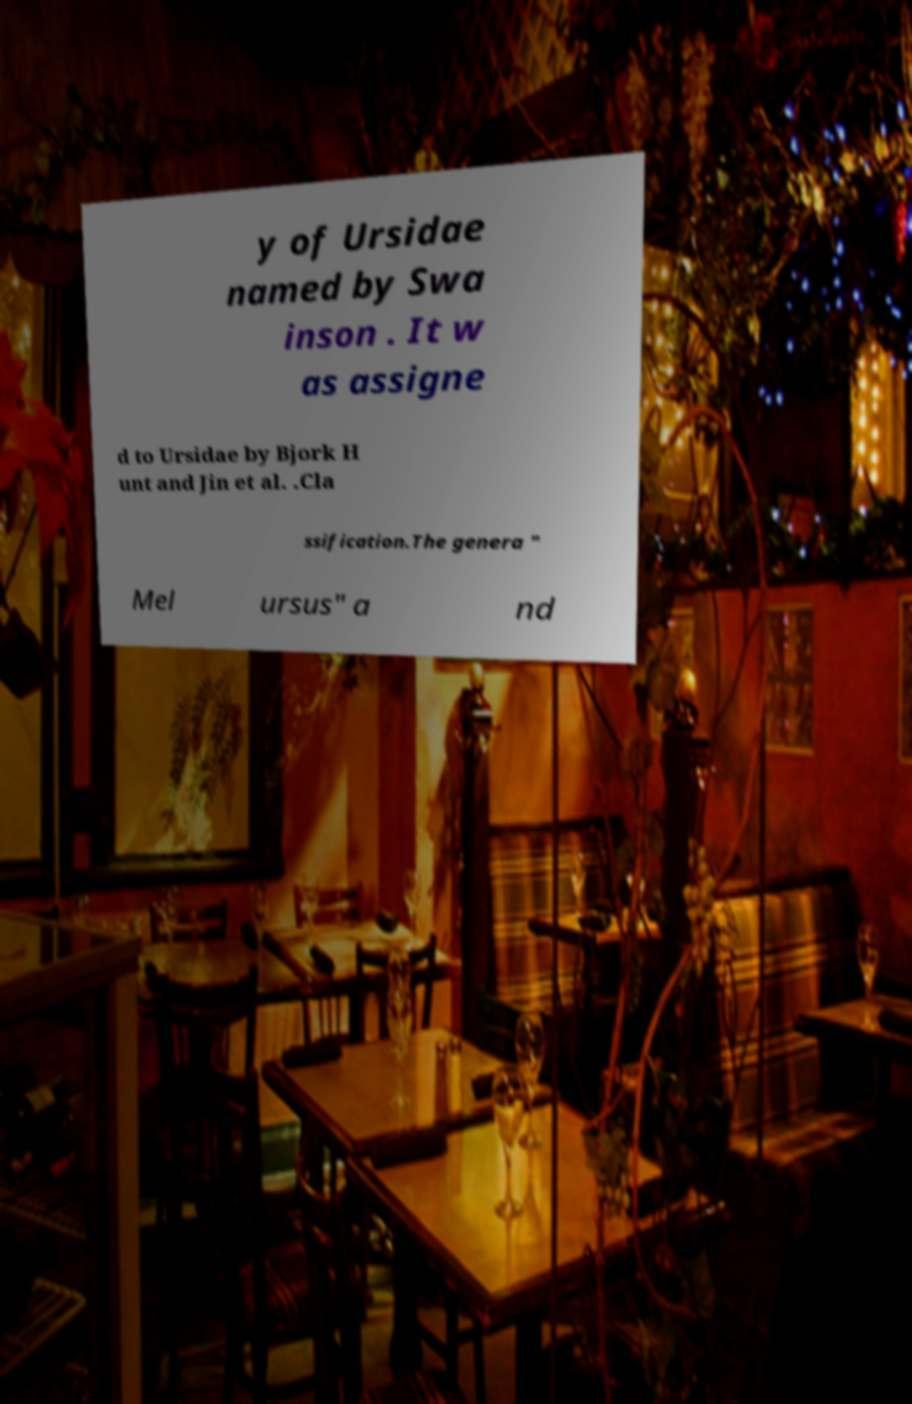Please read and relay the text visible in this image. What does it say? y of Ursidae named by Swa inson . It w as assigne d to Ursidae by Bjork H unt and Jin et al. .Cla ssification.The genera " Mel ursus" a nd 